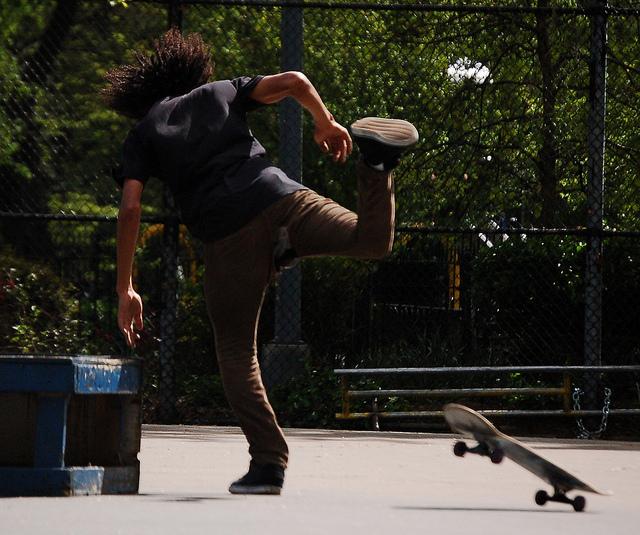Are both feet on the ground?
Write a very short answer. No. Did this person complete the trick?
Quick response, please. No. What are the condition of the man's pants?
Write a very short answer. Ripped. 